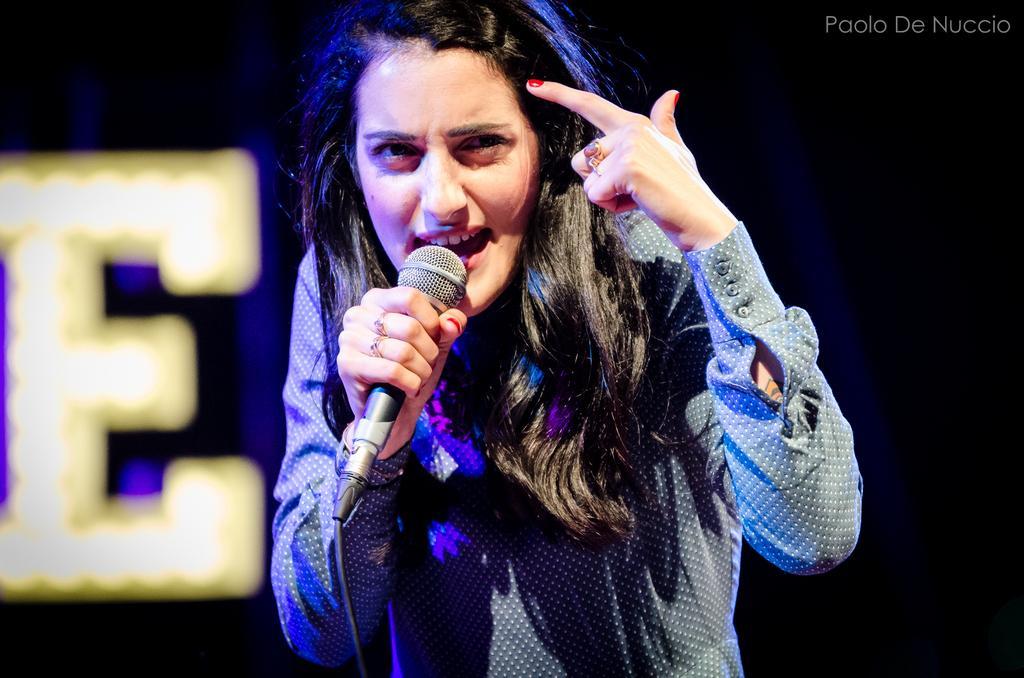Describe this image in one or two sentences. In this image I can see a woman holding a mike in her hand. 